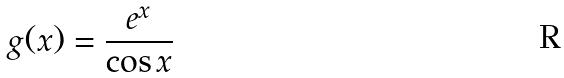Convert formula to latex. <formula><loc_0><loc_0><loc_500><loc_500>g ( x ) = \frac { e ^ { x } } { \cos x }</formula> 